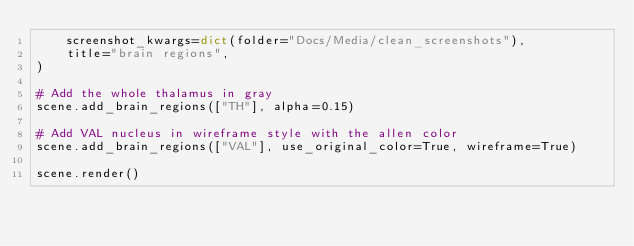Convert code to text. <code><loc_0><loc_0><loc_500><loc_500><_Python_>    screenshot_kwargs=dict(folder="Docs/Media/clean_screenshots"),
    title="brain regions",
)

# Add the whole thalamus in gray
scene.add_brain_regions(["TH"], alpha=0.15)

# Add VAL nucleus in wireframe style with the allen color
scene.add_brain_regions(["VAL"], use_original_color=True, wireframe=True)

scene.render()
</code> 